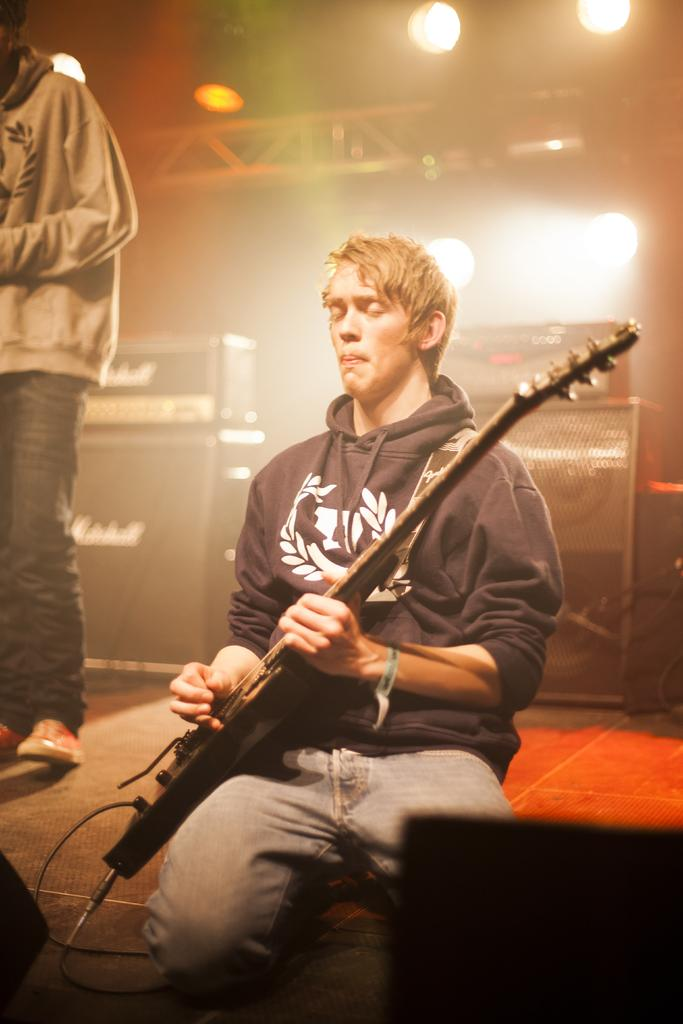How many people are in the image? There are two persons in the image. What is the position of one of the persons? One person is sitting. What is the sitting person holding? The sitting person is holding a guitar in their hands. What type of duck can be seen swimming in the image? There is no duck present in the image; it features two persons, one of whom is sitting and holding a guitar. 